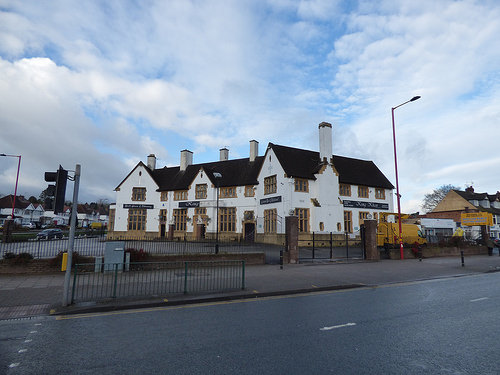<image>
Is there a signal next to the house? No. The signal is not positioned next to the house. They are located in different areas of the scene. 